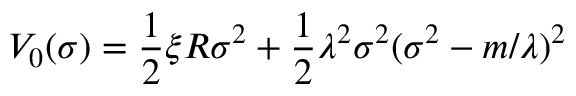Convert formula to latex. <formula><loc_0><loc_0><loc_500><loc_500>V _ { 0 } ( \sigma ) = \frac { 1 } { 2 } \xi R \sigma ^ { 2 } + \frac { 1 } { 2 } \lambda ^ { 2 } \sigma ^ { 2 } ( \sigma ^ { 2 } - m / \lambda ) ^ { 2 }</formula> 